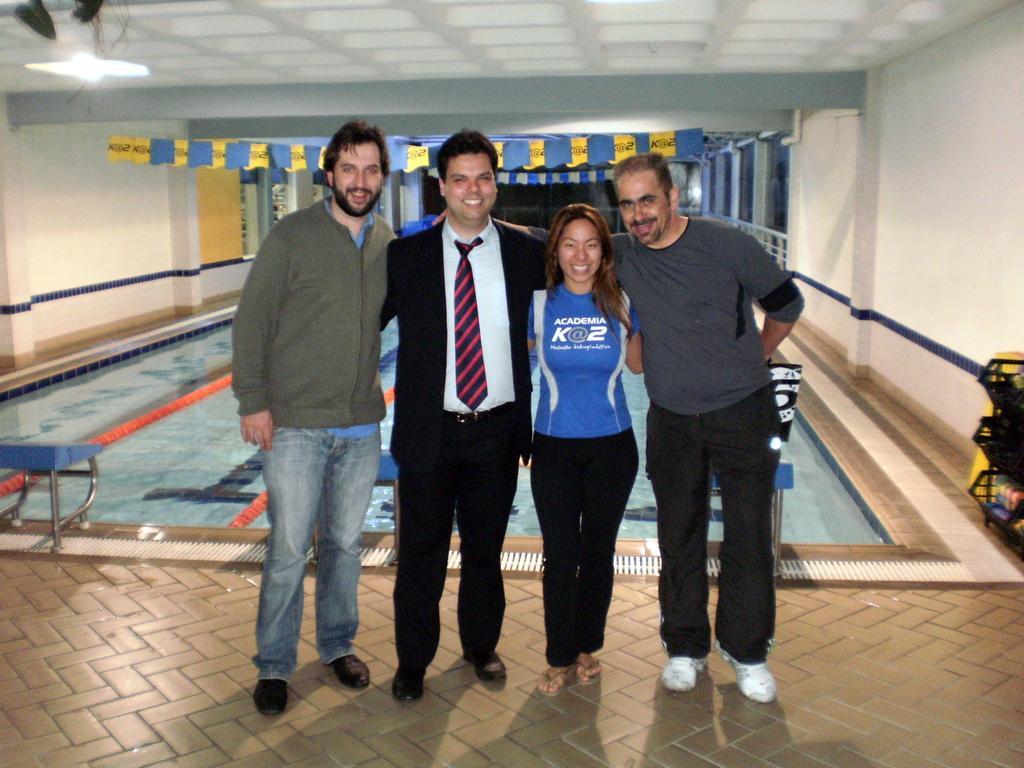How would you summarize this image in a sentence or two? In the image there are four persons standing. Behind them there is a swimming pool. At the top of the image there are flags. And in the background there are walls with windows and pillars. On the right side of the image there is an object. And on the left side of the image there is another object. 